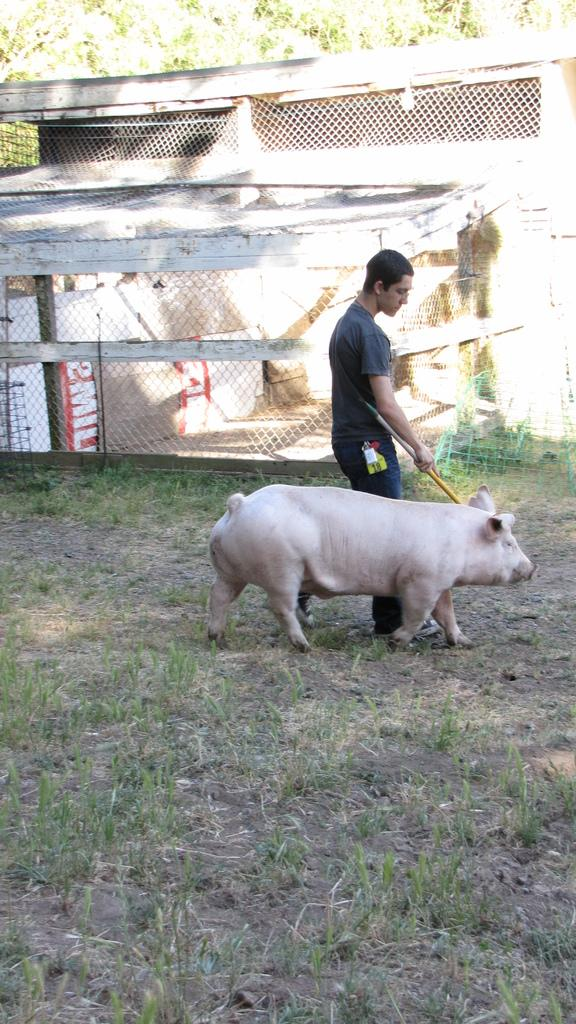What is the man in the image doing? The man is standing in the image and holding a stick in his hand. What is the man holding in his hand? The man is holding a stick in his hand. What animal is present in the image? There is a pig in the image. What type of structure can be seen in the image? There is a house in the image. What type of vegetation is visible in the image? There are trees in the image. What is the ground covered with in the image? The ground is covered with grass in the image. What is the tendency of the man's voice in the image? There is no voice present in the image, as it is a still image and not a video or audio recording. 